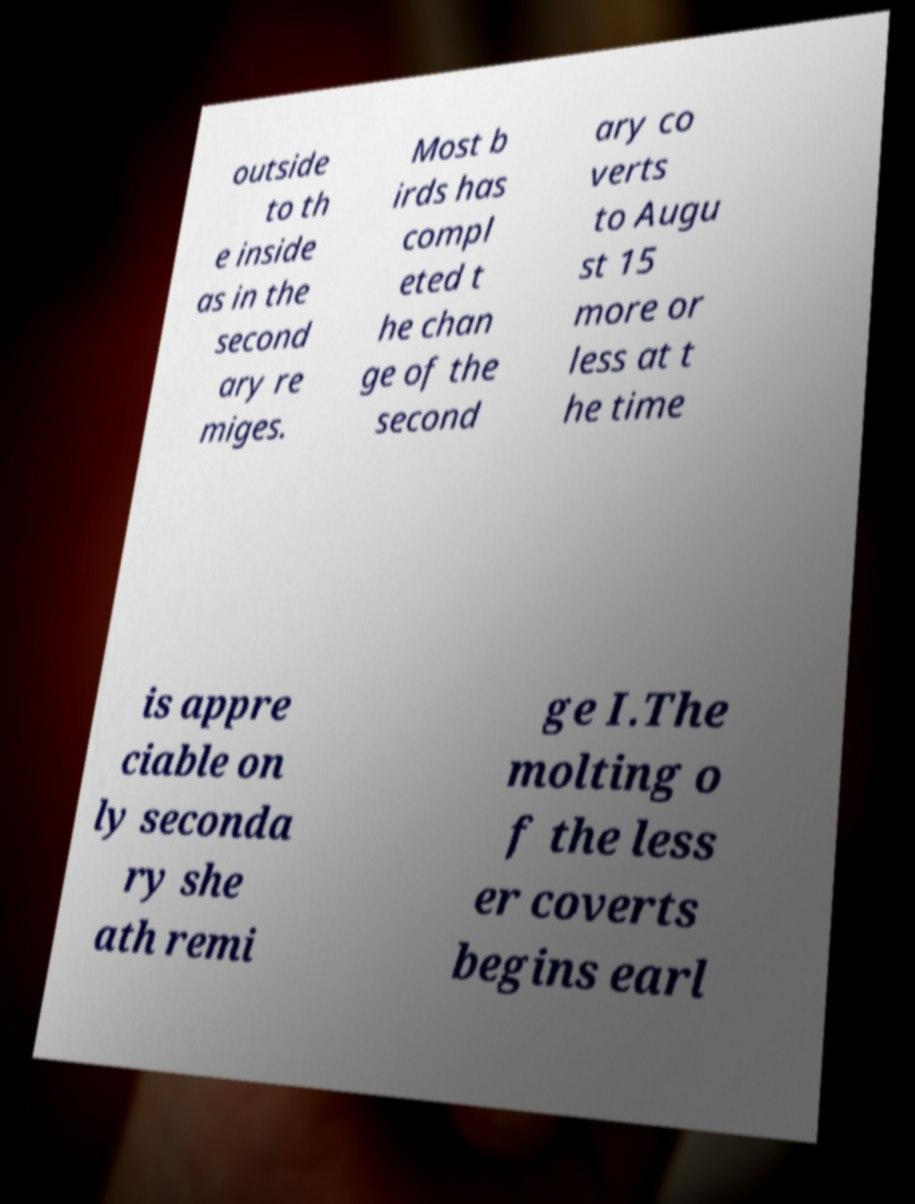I need the written content from this picture converted into text. Can you do that? outside to th e inside as in the second ary re miges. Most b irds has compl eted t he chan ge of the second ary co verts to Augu st 15 more or less at t he time is appre ciable on ly seconda ry she ath remi ge I.The molting o f the less er coverts begins earl 